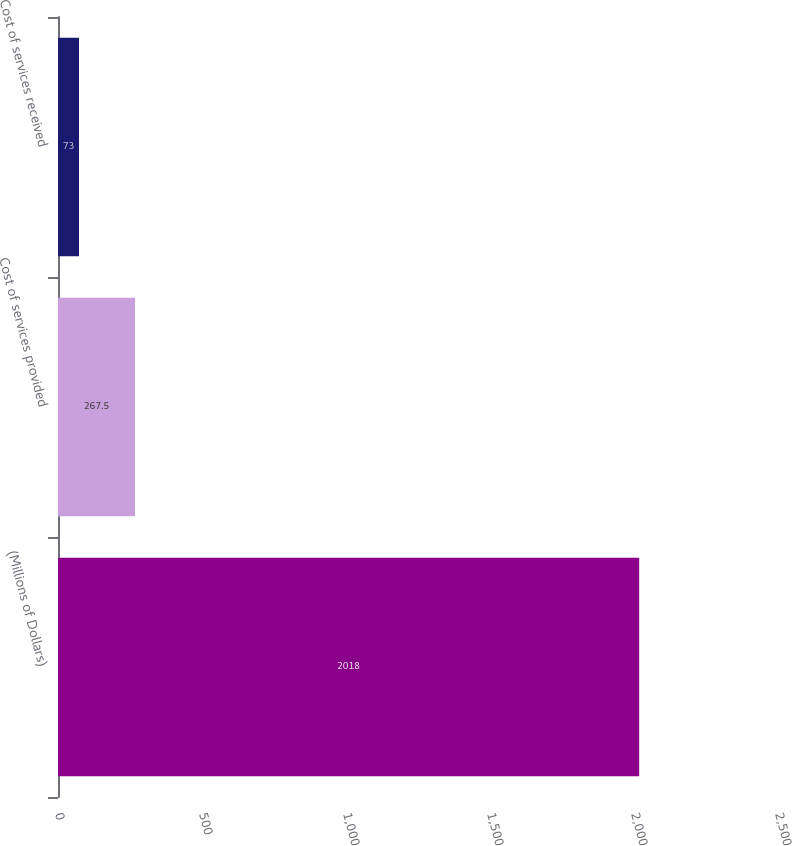<chart> <loc_0><loc_0><loc_500><loc_500><bar_chart><fcel>(Millions of Dollars)<fcel>Cost of services provided<fcel>Cost of services received<nl><fcel>2018<fcel>267.5<fcel>73<nl></chart> 